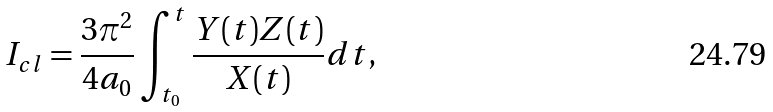Convert formula to latex. <formula><loc_0><loc_0><loc_500><loc_500>I _ { c l } = \frac { 3 \pi ^ { 2 } } { 4 a _ { 0 } } \int _ { t _ { 0 } } ^ { t } \frac { Y ( t ) Z ( t ) } { X ( t ) } d t ,</formula> 